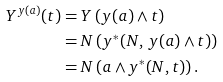<formula> <loc_0><loc_0><loc_500><loc_500>Y ^ { y ( a ) } ( t ) & = Y \left ( y ( a ) \wedge t \right ) \\ & = N \left ( y ^ { * } ( N , \, y ( a ) \wedge t ) \right ) \\ & = N \left ( a \wedge y ^ { * } ( N , t ) \right ) .</formula> 